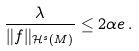Convert formula to latex. <formula><loc_0><loc_0><loc_500><loc_500>\frac { \lambda } { \| f \| _ { { \mathcal { H } } ^ { s } ( M ) } } \leq 2 \alpha e \, .</formula> 